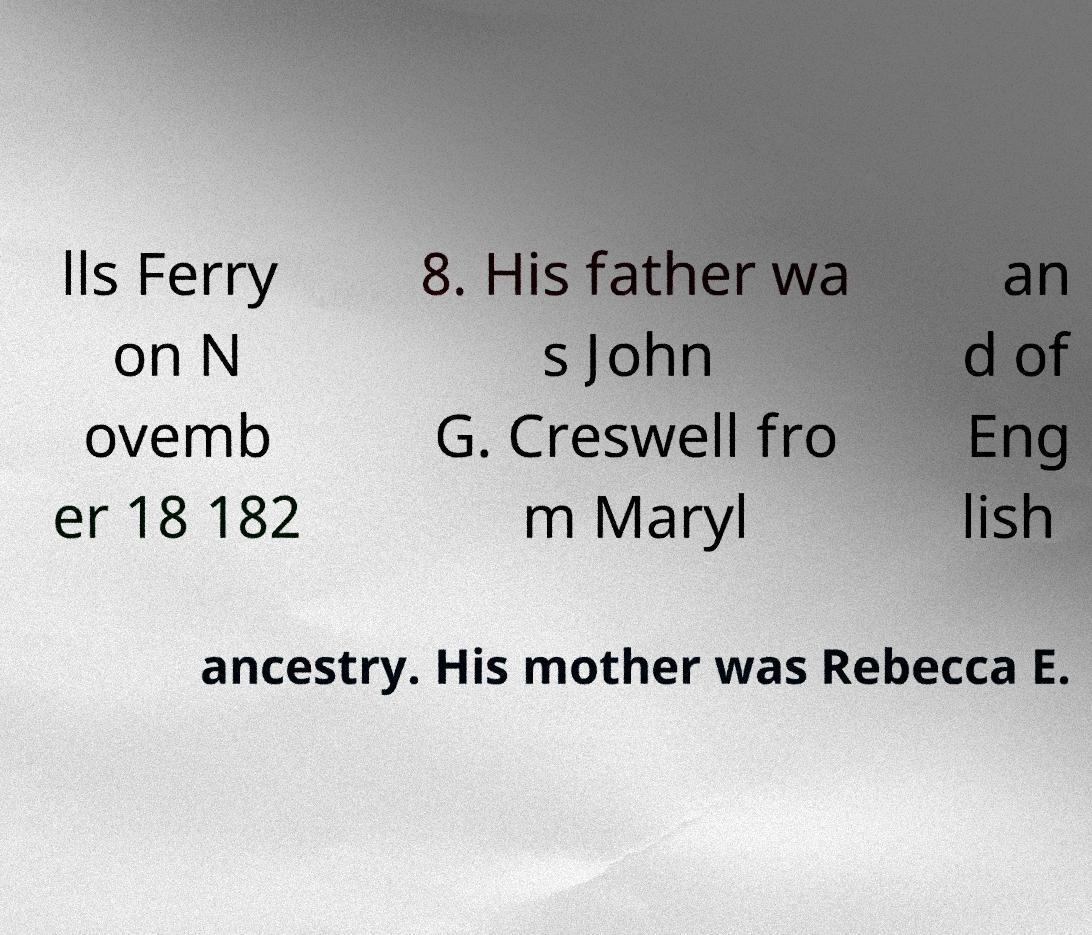I need the written content from this picture converted into text. Can you do that? lls Ferry on N ovemb er 18 182 8. His father wa s John G. Creswell fro m Maryl an d of Eng lish ancestry. His mother was Rebecca E. 